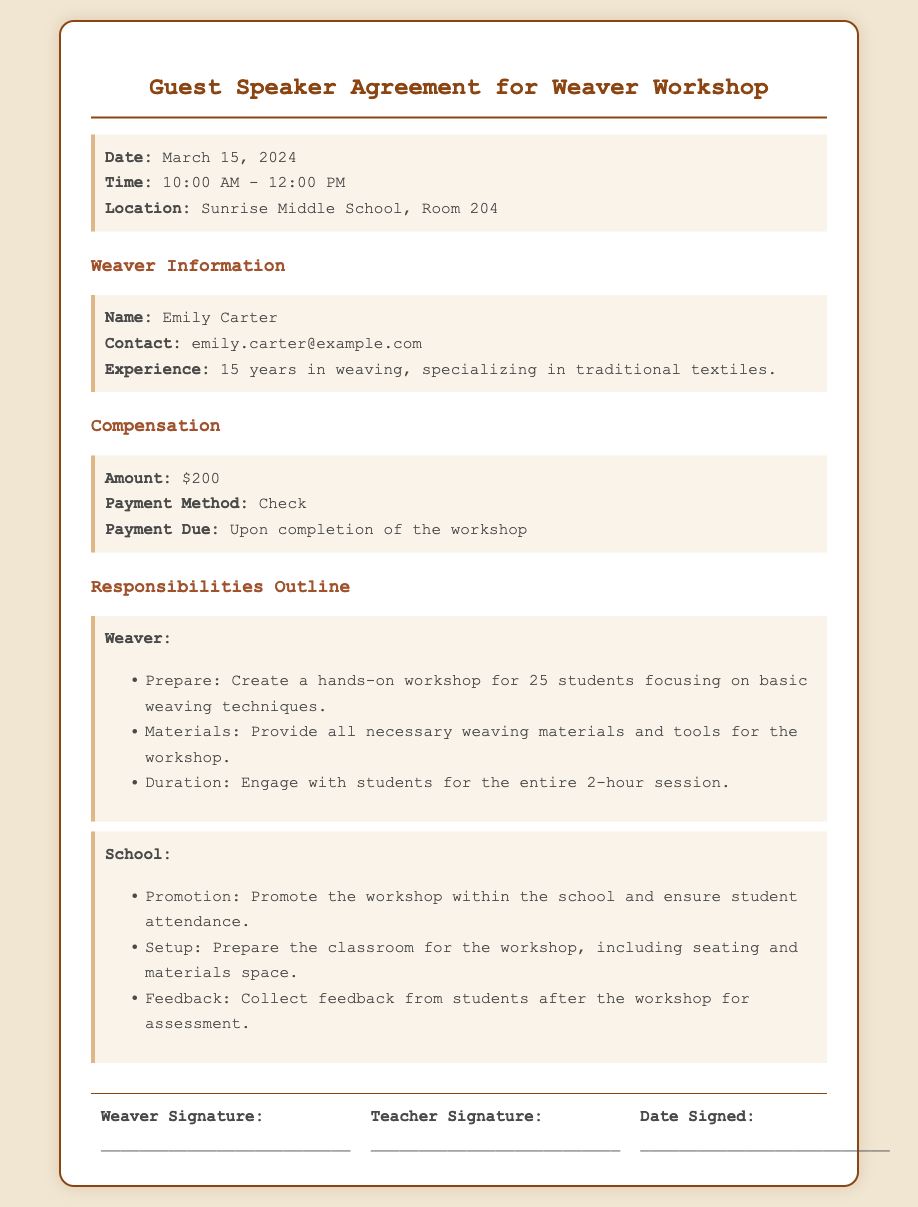What is the date of the workshop? The date of the workshop is explicitly stated in the document as March 15, 2024.
Answer: March 15, 2024 What time does the workshop start? The start time for the workshop is specified as 10:00 AM in the document.
Answer: 10:00 AM How much is the compensation for the weaver? The document clearly outlines that the compensation amount is $200.
Answer: $200 What is the weaver's name? The document provides the name of the weaver as Emily Carter.
Answer: Emily Carter What will the school promote? The school is responsible for promoting the workshop according to the document.
Answer: The workshop What is the location of the workshop? The document mentions that the location is Sunrise Middle School, Room 204.
Answer: Sunrise Middle School, Room 204 What is the duration of the workshop? The duration for the workshop is specified as 2 hours in the document.
Answer: 2 hours What responsibilities does the weaver have? The document outlines that the weaver must prepare a hands-on workshop focusing on basic weaving techniques.
Answer: Prepare a hands-on workshop What payment method is specified for the weaver? The document indicates that the payment method for the weaver is a check.
Answer: Check 